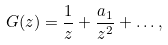<formula> <loc_0><loc_0><loc_500><loc_500>G ( z ) = \frac { 1 } { z } + \frac { a _ { 1 } } { z ^ { 2 } } + \dots ,</formula> 